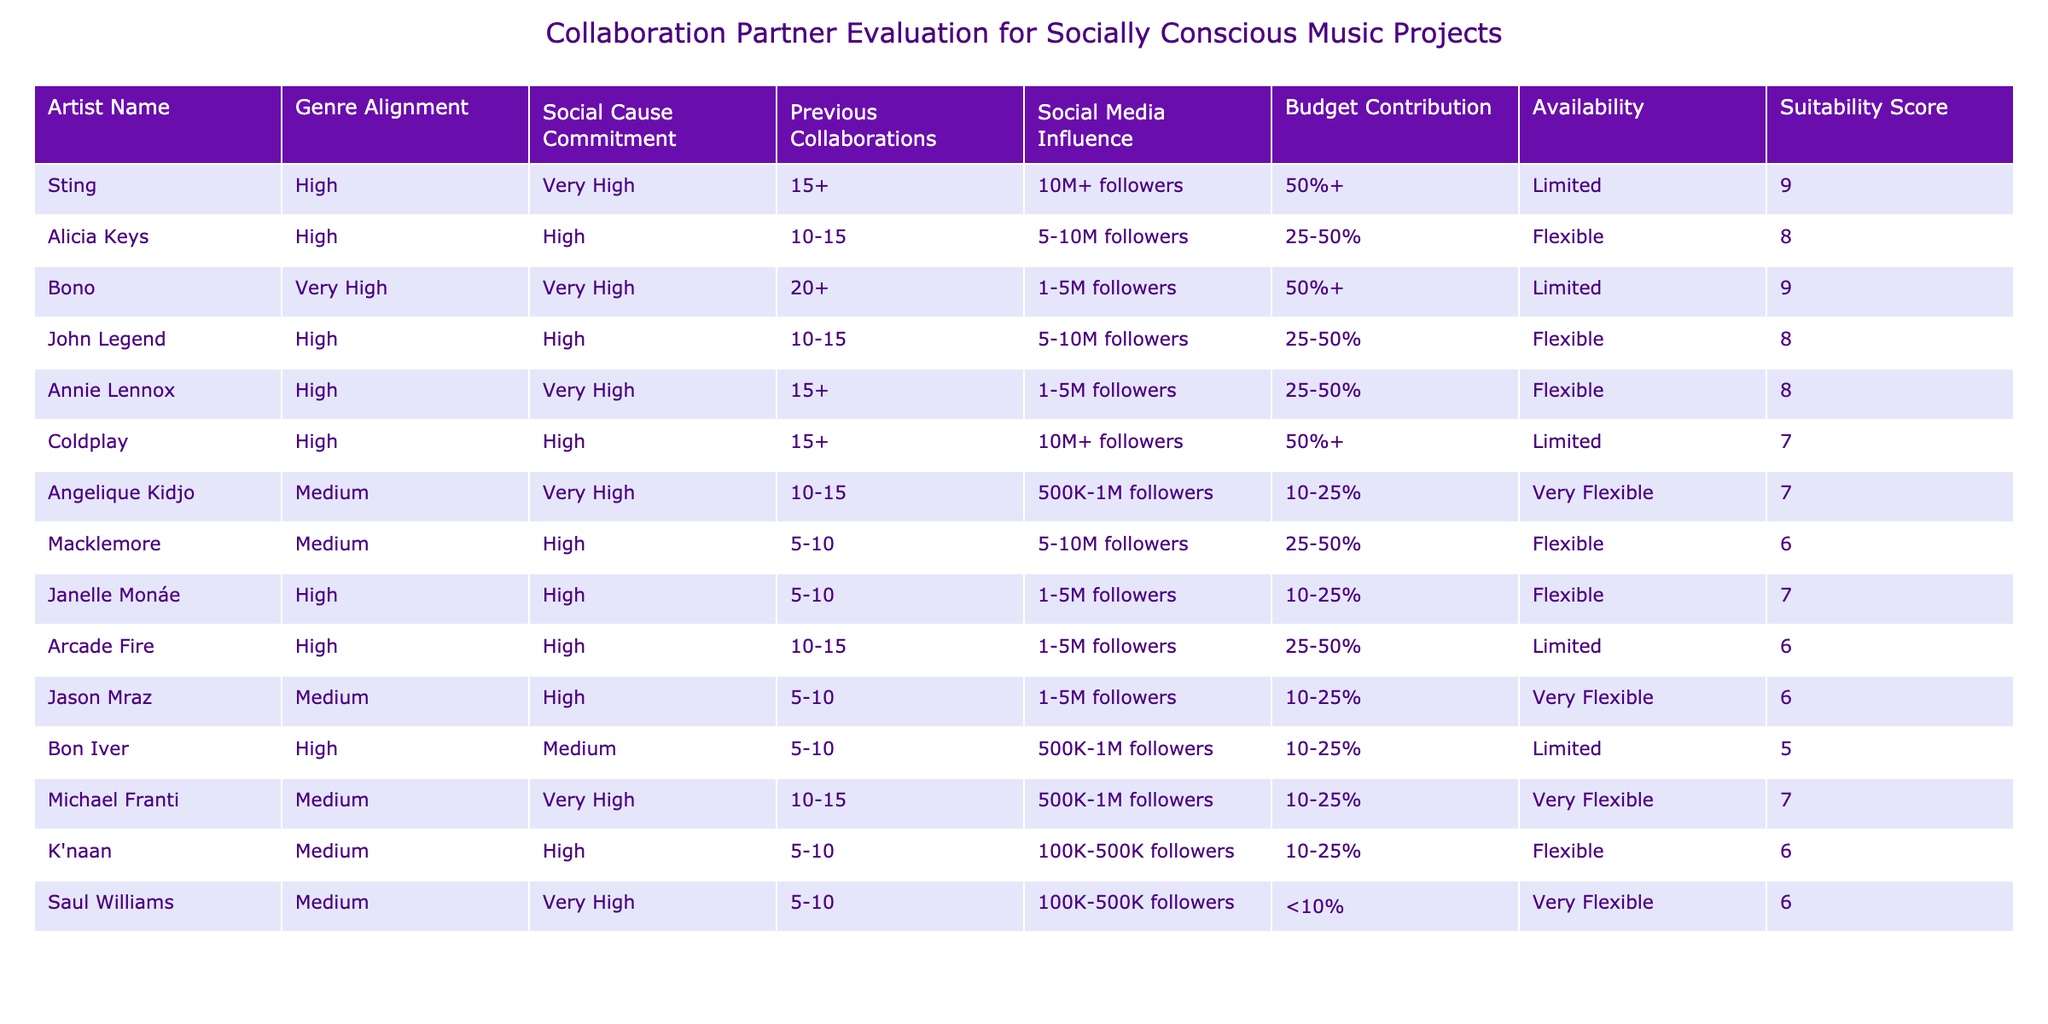What is the artist with the highest suitability score? By scanning the 'Suitability Score' column, I see that both Sting and Bono have the highest score of 9. However, Sting's genre alignment is classified as High and Bono's as Very High, which may indicate a slight preference for Bono in terms of strong alignment to social causes.
Answer: Bono How many artists have a very high commitment to social causes? I count the rows under the 'Social Cause Commitment' column that specify 'Very High.' These are Sting, Bono, Annie Lennox, Michael Franti, and Angelique Kidjo, which totals to 5 artists.
Answer: 5 What is the average budget contribution percentage of all artists? First, I need to convert the budget contributions into numerical values: for instance, 50%+, 25-50%, etc. For the purpose of this calculation, I will use the midpoints or best estimates for each group: 50, 37.5, 10, and so on, based on what is specified. Summing these values gives 37.5 + 37.5 + 50 + 37.5 + 37.5 + 25 + 17.5 + 20 + 20 + 7.5 + 25 + 17.5 + 7.5 + 7.5 + 7.5 = 469.5. Divided by 14 (the number of artists), the average is approximately 33.5.
Answer: 33.5 Are there any artists with limited availability and a suitable score of 7 or higher? Looking at the 'Availability' column, I find Coldplay and Bon Iver. Coldplay has a suitability score of 7, and Bon Iver has a score of 5, thus only Coldplay has a suitability score of 7 or higher.
Answer: Yes Which artist has the lowest suitability score, and what is their genre alignment? The artist with the lowest suitability score of 5 is Bon Iver. Referring to the 'Genre Alignment' column, Bon Iver is classified as Medium.
Answer: Bon Iver, Medium 